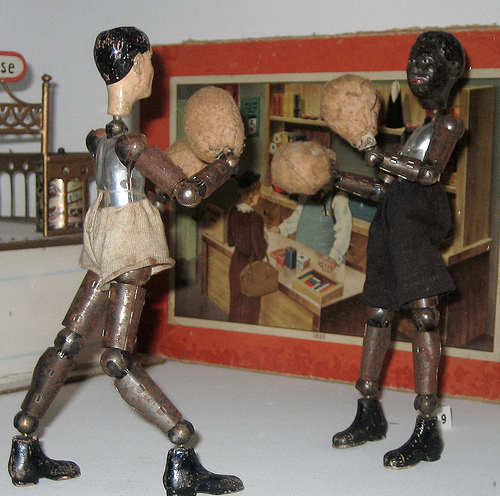<image>
Can you confirm if the boxing gloves is above the shoes? Yes. The boxing gloves is positioned above the shoes in the vertical space, higher up in the scene. 